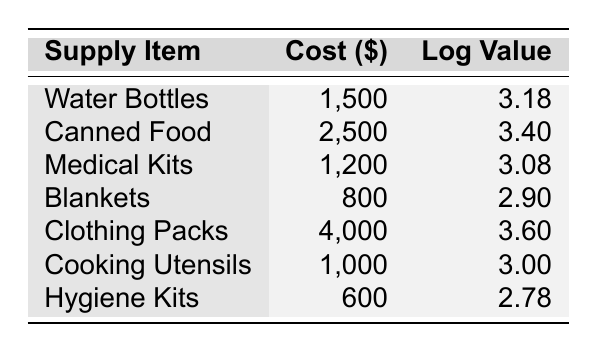What is the cost of Canned Food? The table lists Canned Food with a cost value of 2500.
Answer: 2500 Which supply item has the highest logarithmic value? The item with the highest logarithmic value is Clothing Packs, which has a log value of 3.60.
Answer: Clothing Packs What is the difference in cost between the most expensive supply item and the least expensive supply item? The cost of Clothing Packs is 4000 and the cost of Hygiene Kits is 600. The difference is 4000 - 600 = 3400.
Answer: 3400 True or False: The cost of Water Bottles is greater than the cost of Medical Kits. The cost of Water Bottles is 1500 and the cost of Medical Kits is 1200, thus 1500 is greater than 1200.
Answer: True What is the average cost of the resettlement supplies listed in the table? First, we calculate the sum: 1500 + 2500 + 1200 + 800 + 4000 + 1000 + 600 = 10500. Then, we divide by the number of items (7): 10500 / 7 = 1500.
Answer: 1500 What is the total logarithmic value of all the supplies? Adding the logarithmic values: 3.17609 + 3.39794 + 3.07918 + 2.90309 + 3.60206 + 3.00000 + 2.77815 = 18.93641.
Answer: 18.93641 Which supply item has a cost closer to the average cost? The average cost is 1500. The supply item closest to this is Water Bottles at 1500.
Answer: Water Bottles True or False: All supply items listed have a logarithmic value greater than 3. The Hygiene Kits have a logarithmic value of 2.78, which is less than 3, so this statement is false.
Answer: False 